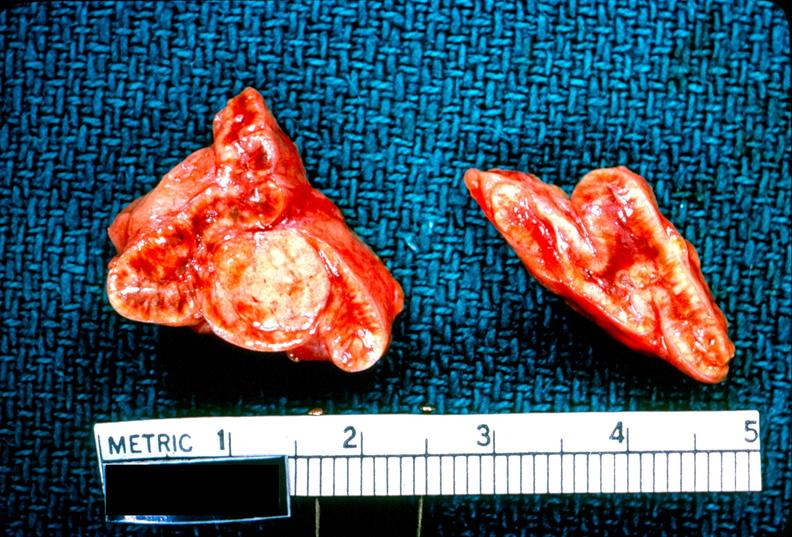does surface show adrenal, cortical adenoma aldosteronism?
Answer the question using a single word or phrase. No 